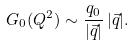Convert formula to latex. <formula><loc_0><loc_0><loc_500><loc_500>G _ { 0 } ( Q ^ { 2 } ) \sim \frac { q _ { 0 } } { | \vec { q } | } \, | \vec { q } | .</formula> 